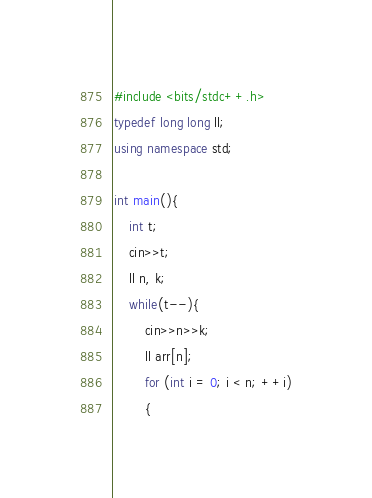Convert code to text. <code><loc_0><loc_0><loc_500><loc_500><_C++_>#include <bits/stdc++.h>
typedef long long ll;
using namespace std;

int main(){
	int t;
	cin>>t;
	ll n, k;
	while(t--){
		cin>>n>>k;
		ll arr[n];
		for (int i = 0; i < n; ++i)
		{</code> 